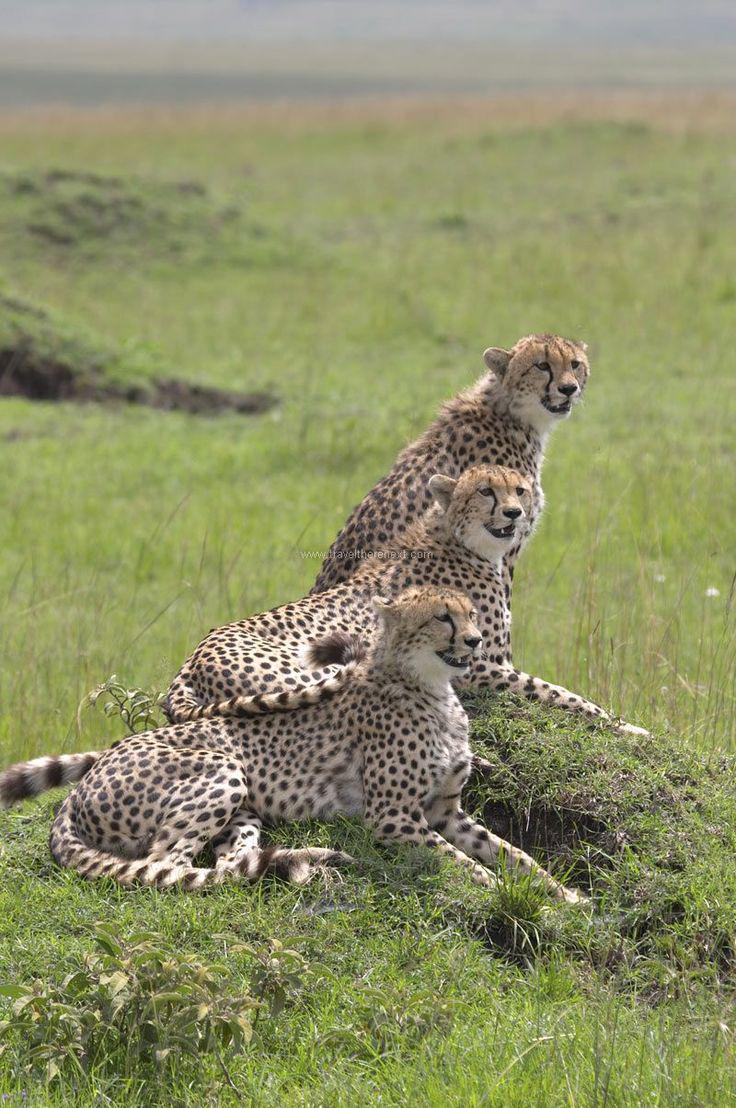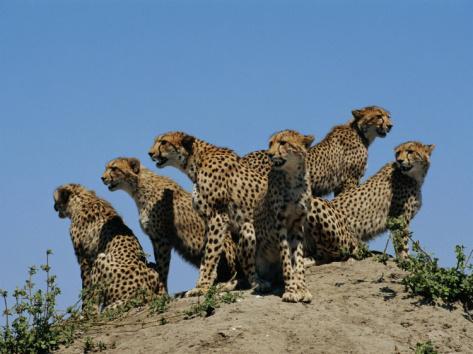The first image is the image on the left, the second image is the image on the right. Assess this claim about the two images: "There are at most 3 cheetahs in the image pair". Correct or not? Answer yes or no. No. 